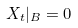Convert formula to latex. <formula><loc_0><loc_0><loc_500><loc_500>X _ { t } | _ { B } = 0</formula> 